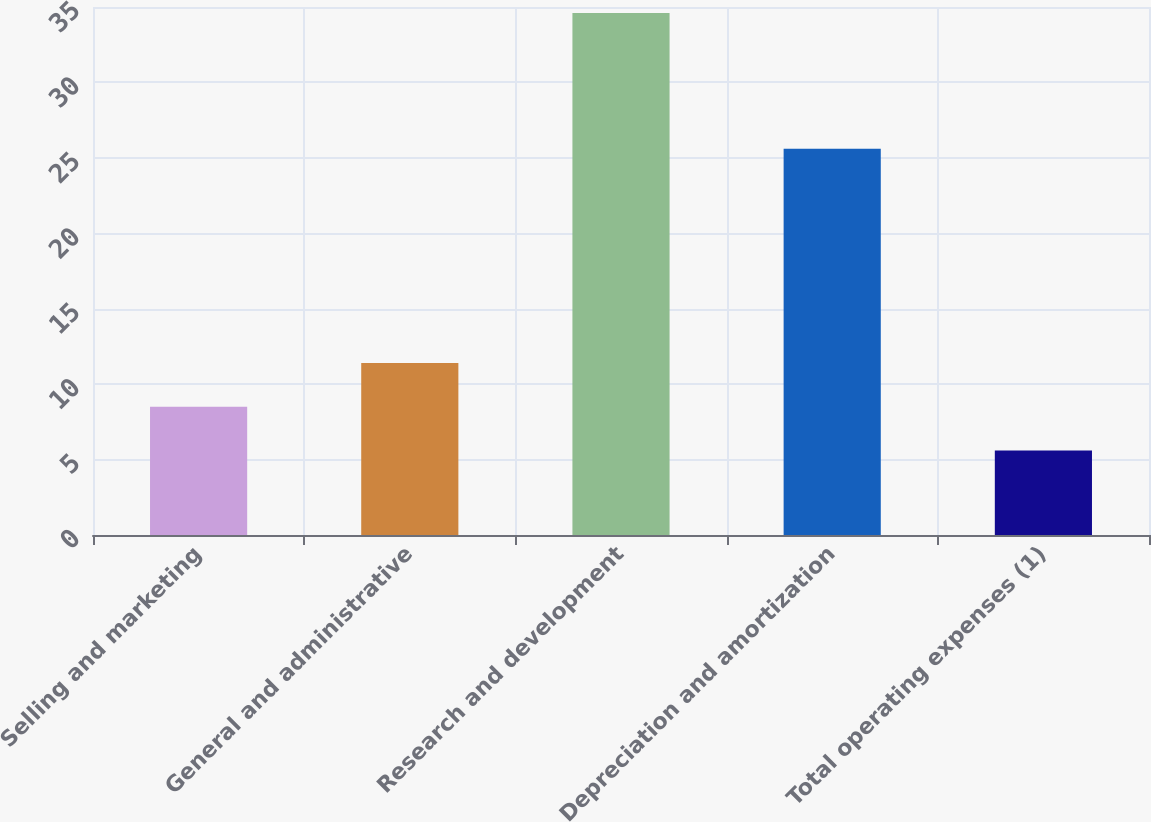Convert chart. <chart><loc_0><loc_0><loc_500><loc_500><bar_chart><fcel>Selling and marketing<fcel>General and administrative<fcel>Research and development<fcel>Depreciation and amortization<fcel>Total operating expenses (1)<nl><fcel>8.5<fcel>11.4<fcel>34.6<fcel>25.6<fcel>5.6<nl></chart> 